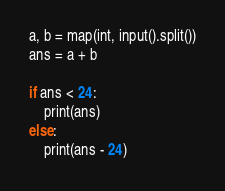Convert code to text. <code><loc_0><loc_0><loc_500><loc_500><_Python_>a, b = map(int, input().split())
ans = a + b

if ans < 24:
    print(ans)
else:
    print(ans - 24)</code> 